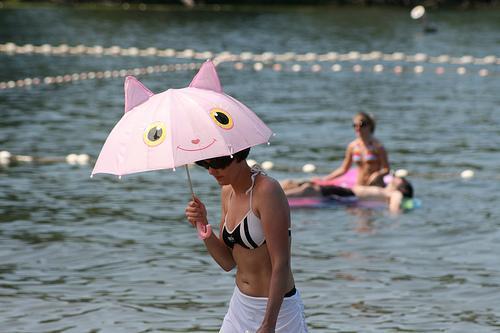How many people are in this picture?
Give a very brief answer. 3. 